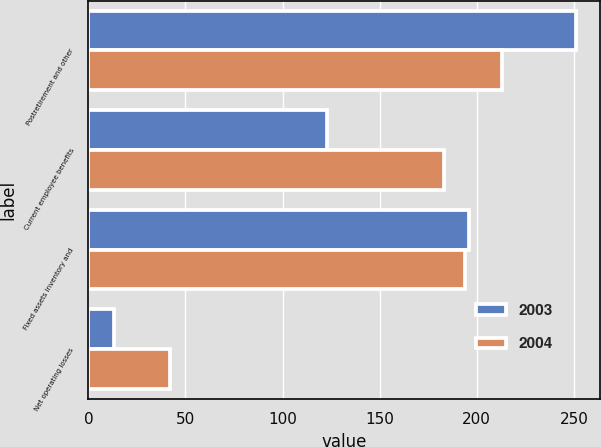Convert chart to OTSL. <chart><loc_0><loc_0><loc_500><loc_500><stacked_bar_chart><ecel><fcel>Postretirement and other<fcel>Current employee benefits<fcel>Fixed assets inventory and<fcel>Net operating losses<nl><fcel>2003<fcel>251<fcel>123<fcel>196<fcel>13<nl><fcel>2004<fcel>213<fcel>183<fcel>194<fcel>42<nl></chart> 